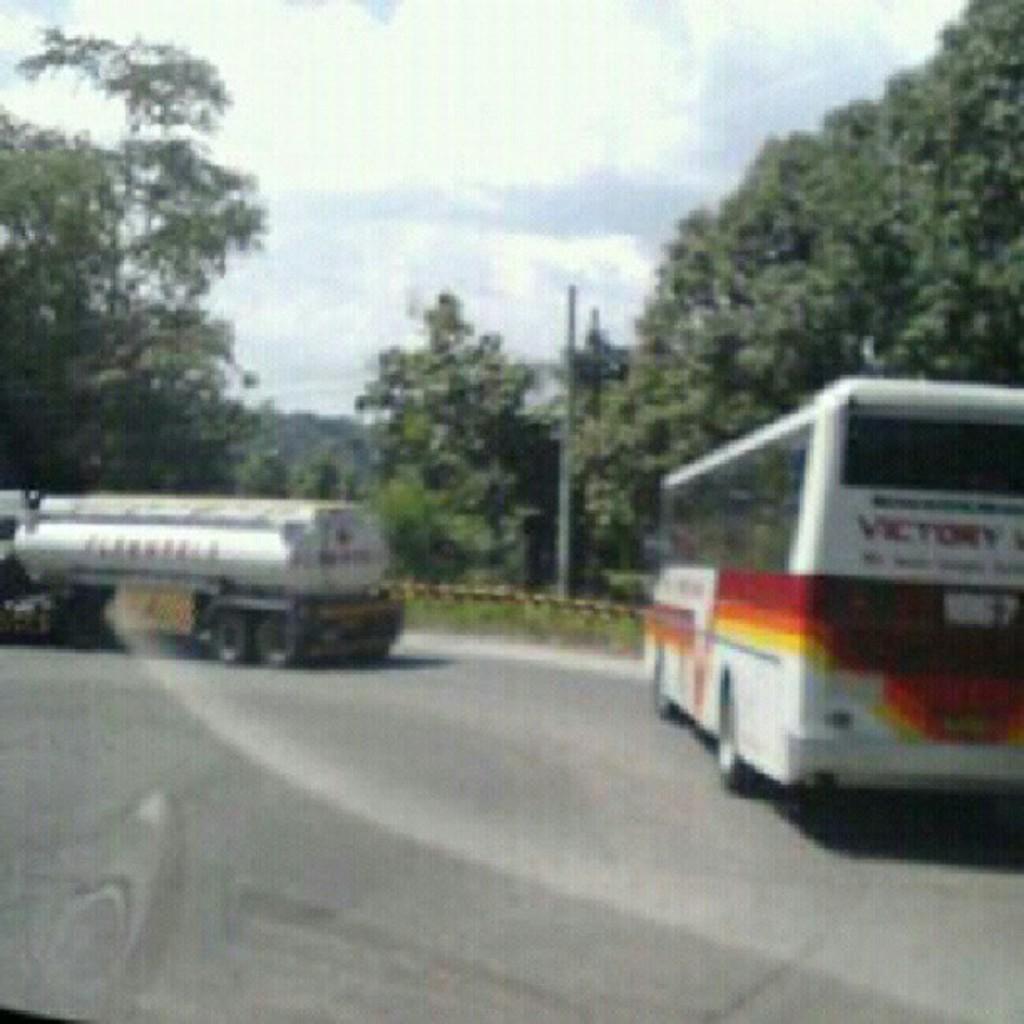Could you give a brief overview of what you see in this image? In the image we can see there is a bus and a vehicle parked on the road. There is a street light pole and there are lot of trees. There is a cloudy sky. 